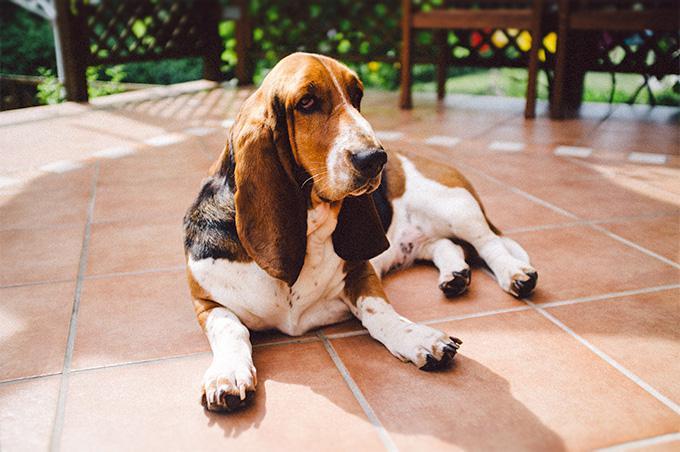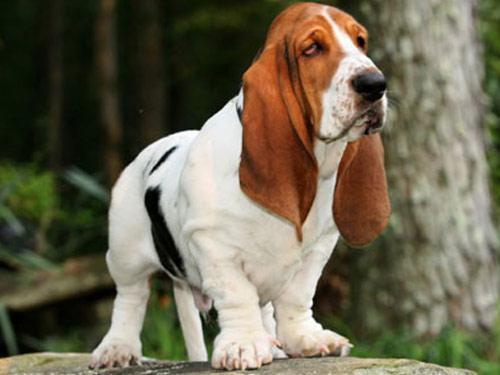The first image is the image on the left, the second image is the image on the right. Given the left and right images, does the statement "In one image, a dog with big floppy ears is running." hold true? Answer yes or no. No. The first image is the image on the left, the second image is the image on the right. Examine the images to the left and right. Is the description "One image shows a basset hound bounding toward the camera." accurate? Answer yes or no. No. 